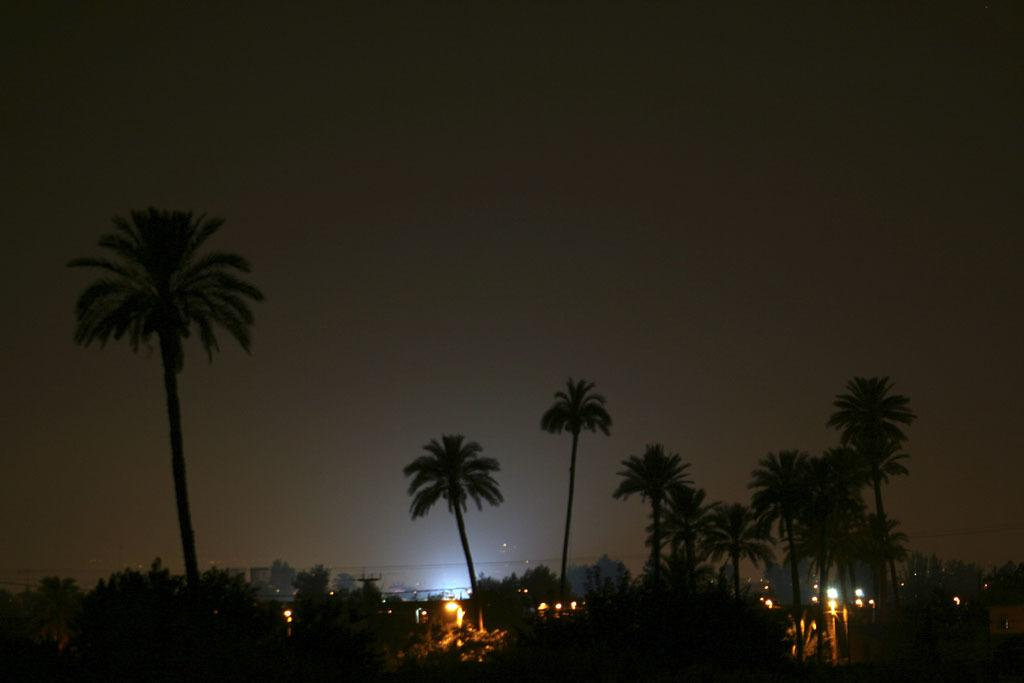What type of vegetation can be seen in the image? There are trees in the image. What structures are present in the image that have lights attached to them? There are poles with lights in the image. How would you describe the appearance of the sky in the image? The sky is dark in the image. Can you see a list hanging from one of the trees in the image? There is no list present in the image; only trees, poles with lights, and a dark sky are visible. Are there any cobwebs visible on the poles with lights in the image? There is no mention of cobwebs in the image, and they are not visible in the provided facts. 